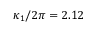<formula> <loc_0><loc_0><loc_500><loc_500>\kappa _ { 1 } / 2 \pi = 2 . 1 2</formula> 